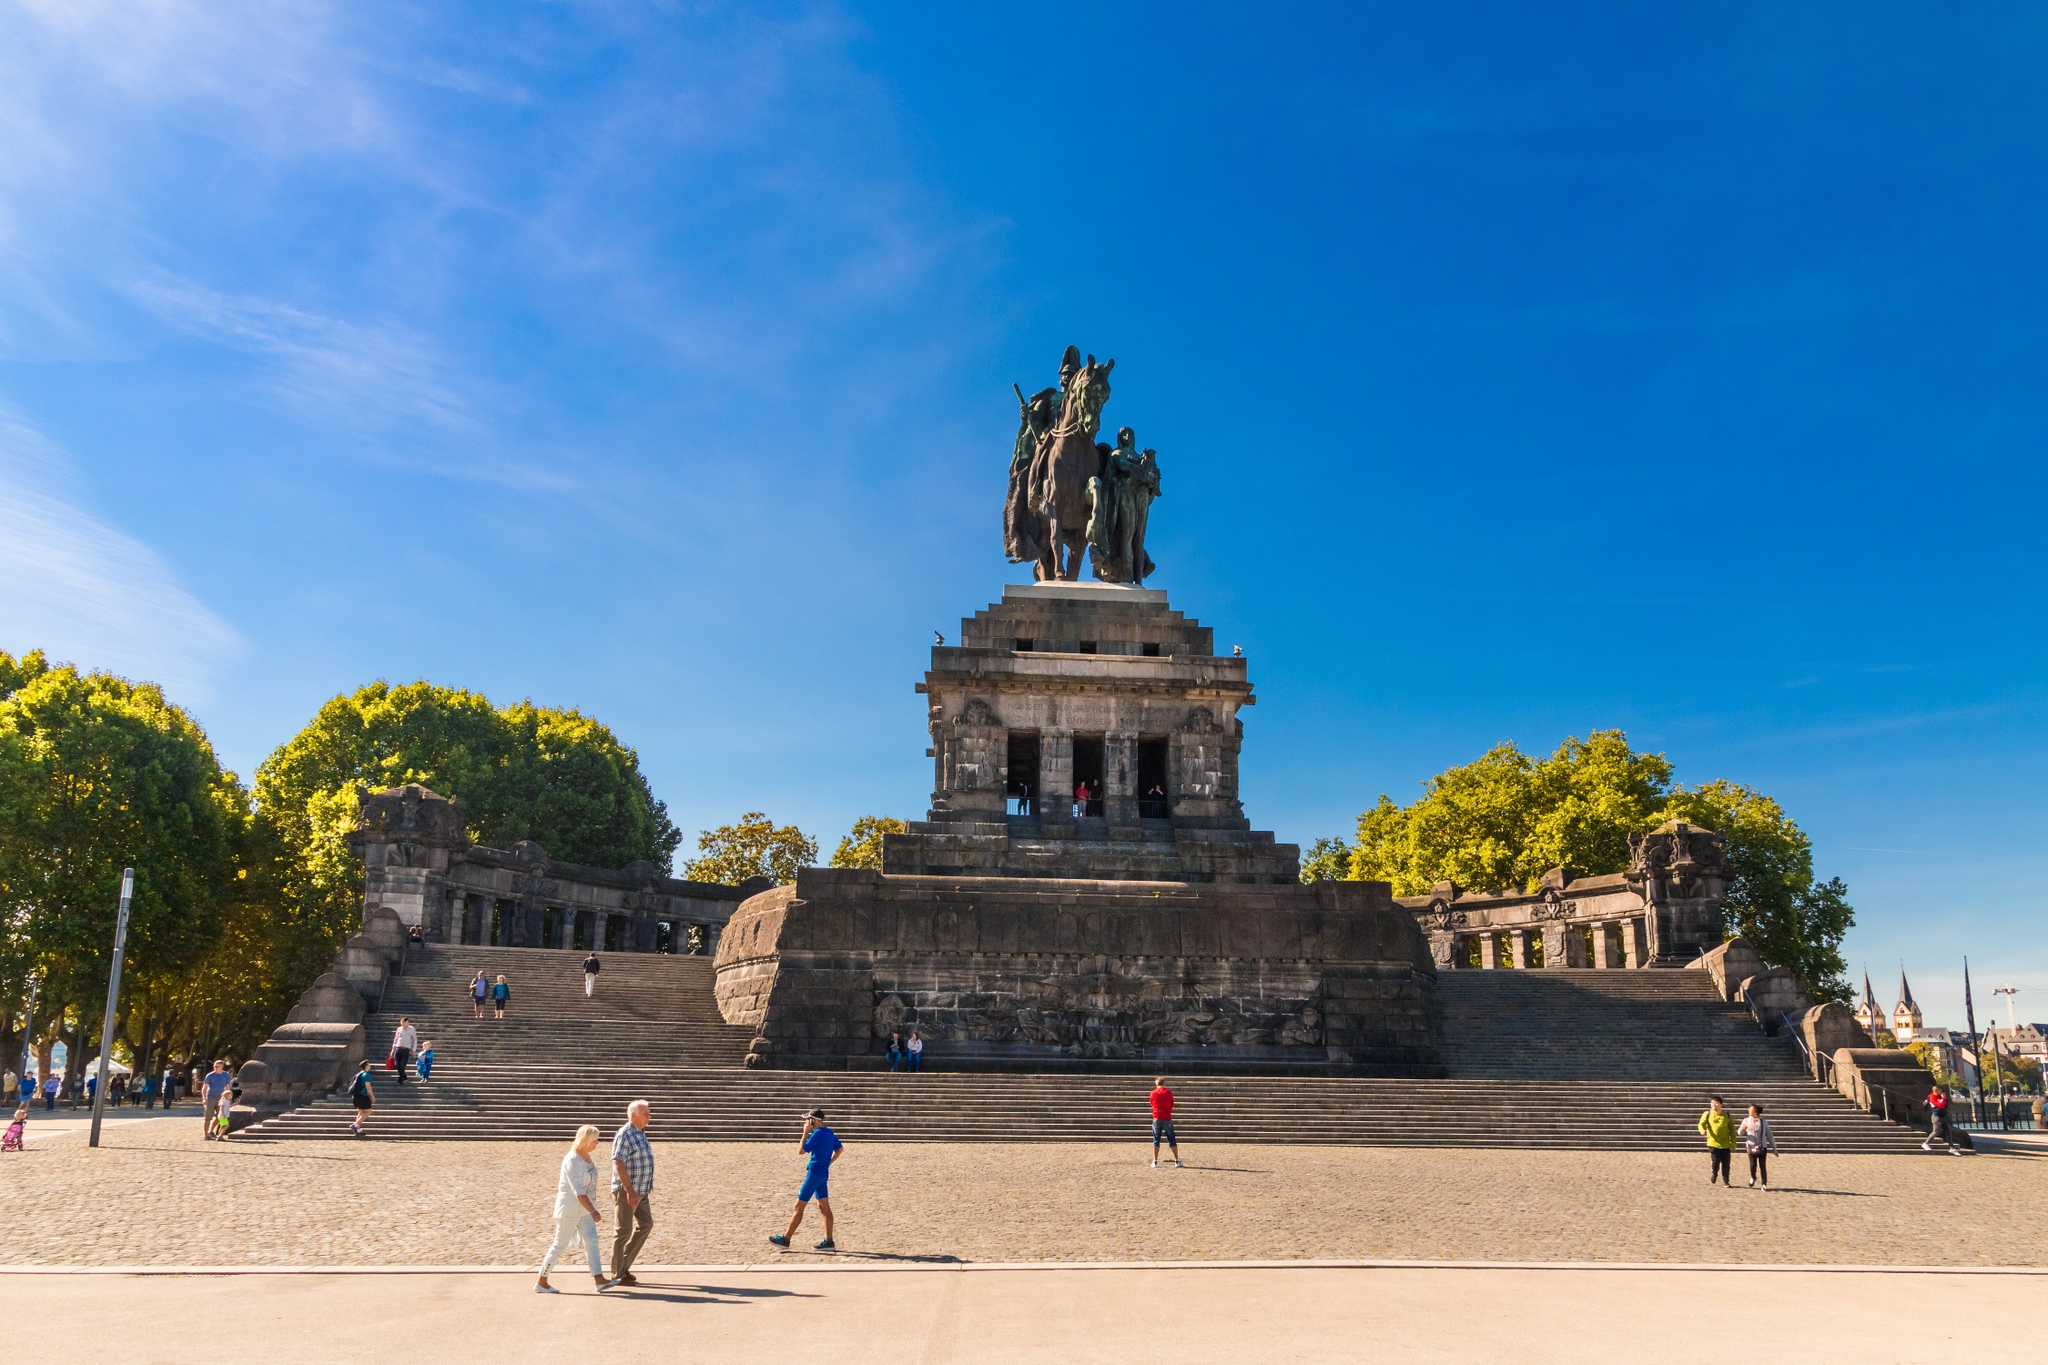What is the significance of the trees around the monument? The trees surrounding the monument at Deutsches Eck provide a natural frame to the site, embedding it within its broader landscape. Their presence contrasts the formidable stone architecture with lush greenery, symbolizing the balance between human achievement and nature's beauty. These trees also offer shade and a sense of tranquility, enhancing the site's appeal as a place of relaxation and reflection, thus playing a crucial role in the visitor experience. The greenery adds a sense of continuity and life to the historical setting, suggesting that while human endeavors may be monumental, they are part of a living, ongoing natural world. 